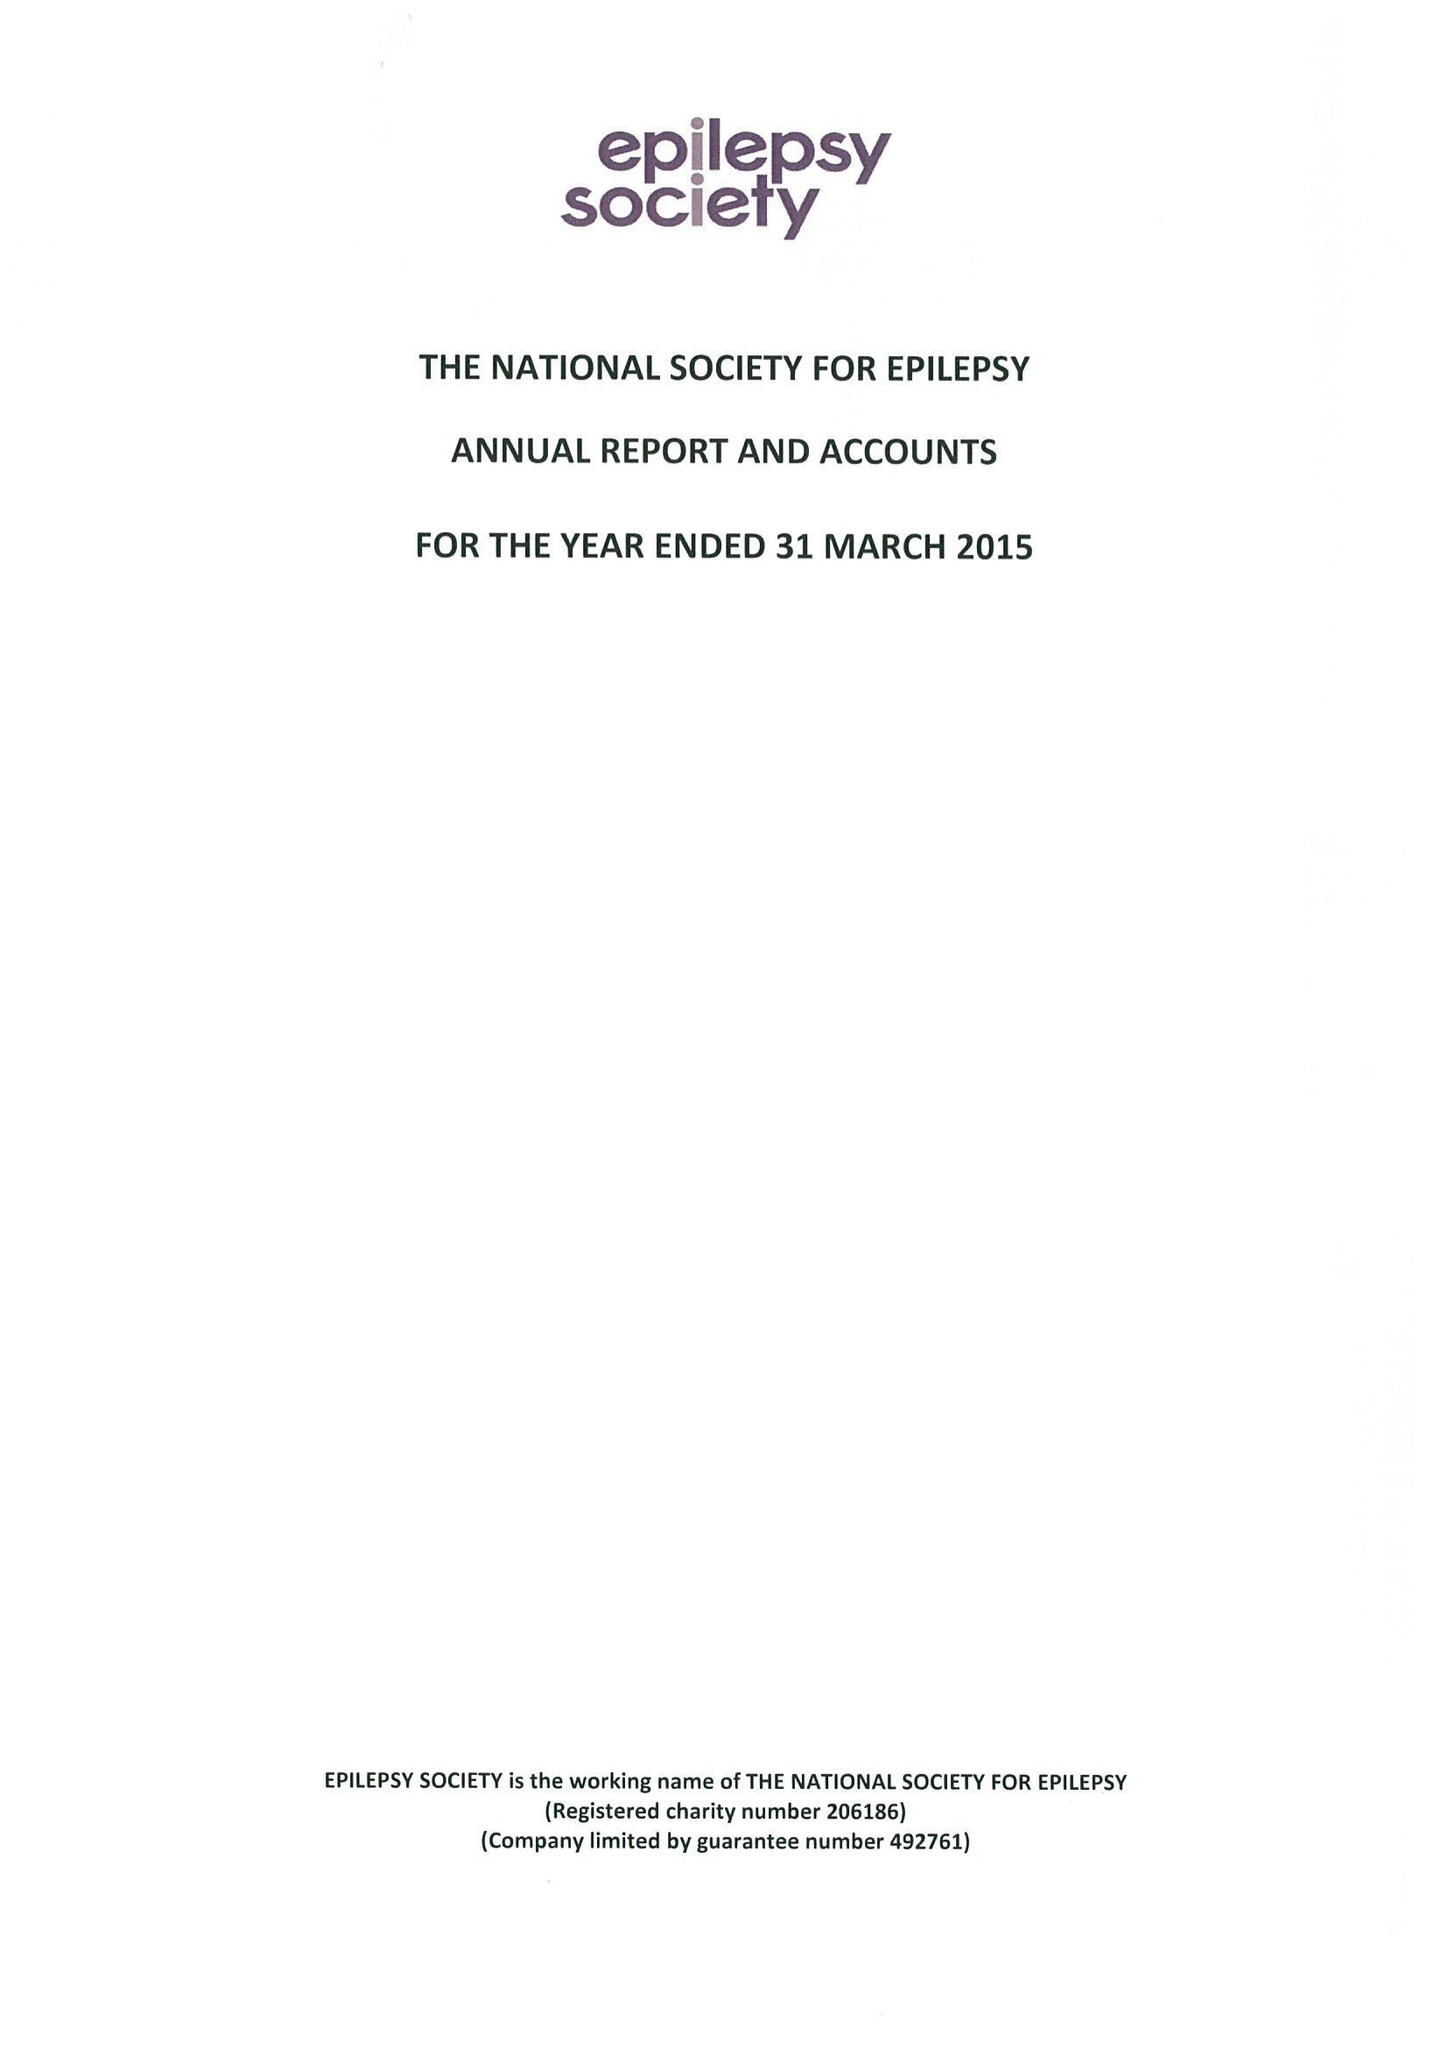What is the value for the address__street_line?
Answer the question using a single word or phrase. CHESHAM LANE 